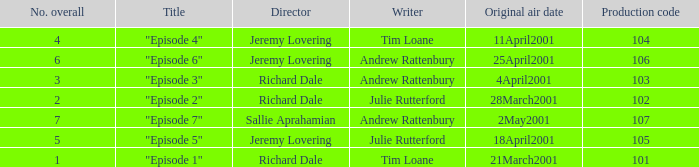When did the episode first air that had a production code of 102? 28March2001. 